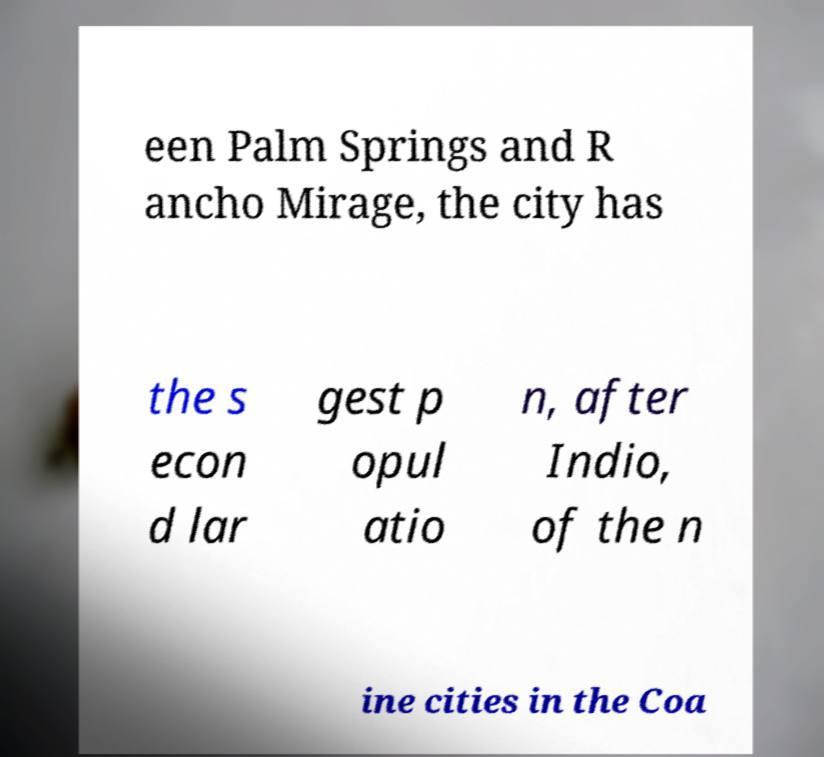Please identify and transcribe the text found in this image. een Palm Springs and R ancho Mirage, the city has the s econ d lar gest p opul atio n, after Indio, of the n ine cities in the Coa 